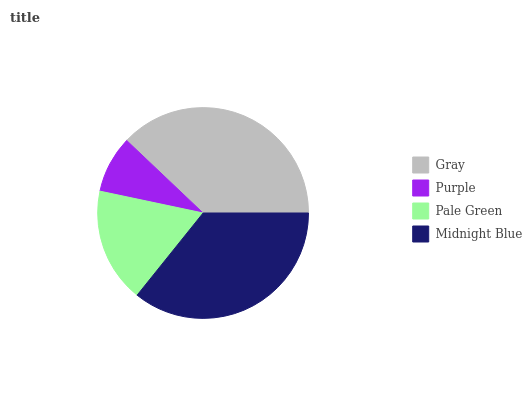Is Purple the minimum?
Answer yes or no. Yes. Is Gray the maximum?
Answer yes or no. Yes. Is Pale Green the minimum?
Answer yes or no. No. Is Pale Green the maximum?
Answer yes or no. No. Is Pale Green greater than Purple?
Answer yes or no. Yes. Is Purple less than Pale Green?
Answer yes or no. Yes. Is Purple greater than Pale Green?
Answer yes or no. No. Is Pale Green less than Purple?
Answer yes or no. No. Is Midnight Blue the high median?
Answer yes or no. Yes. Is Pale Green the low median?
Answer yes or no. Yes. Is Gray the high median?
Answer yes or no. No. Is Midnight Blue the low median?
Answer yes or no. No. 